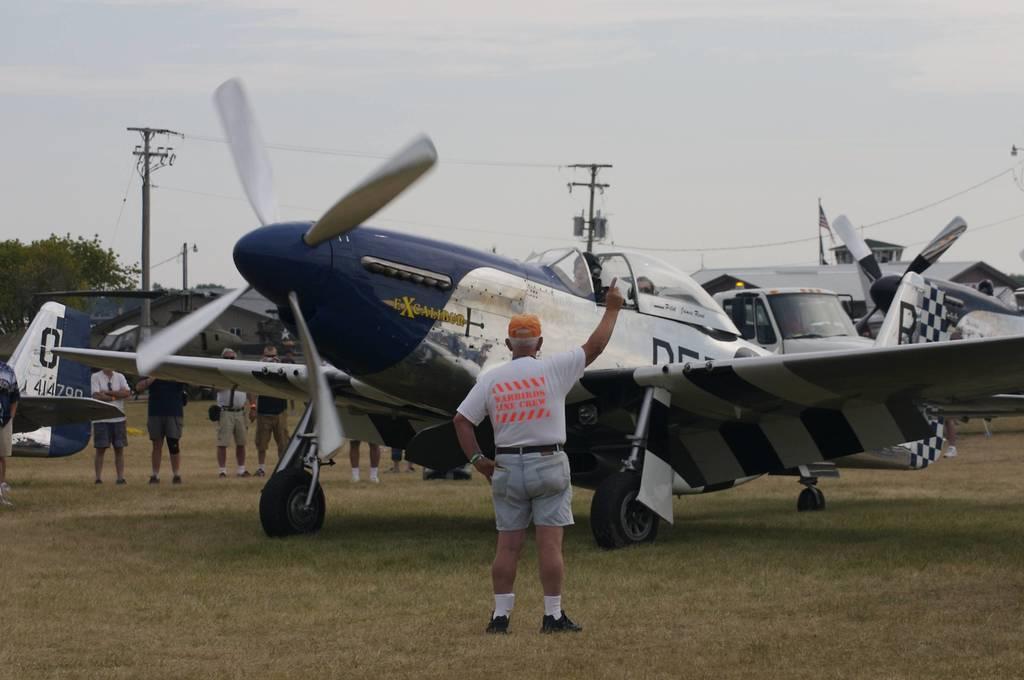Could you give a brief overview of what you see in this image? In front of the image there is a person standing and raising his hand, behind him there are aircraft's and some other people around, in the background of the image there are trees and electric poles with cables on it. At the top of the image there are clouds in the sky. 